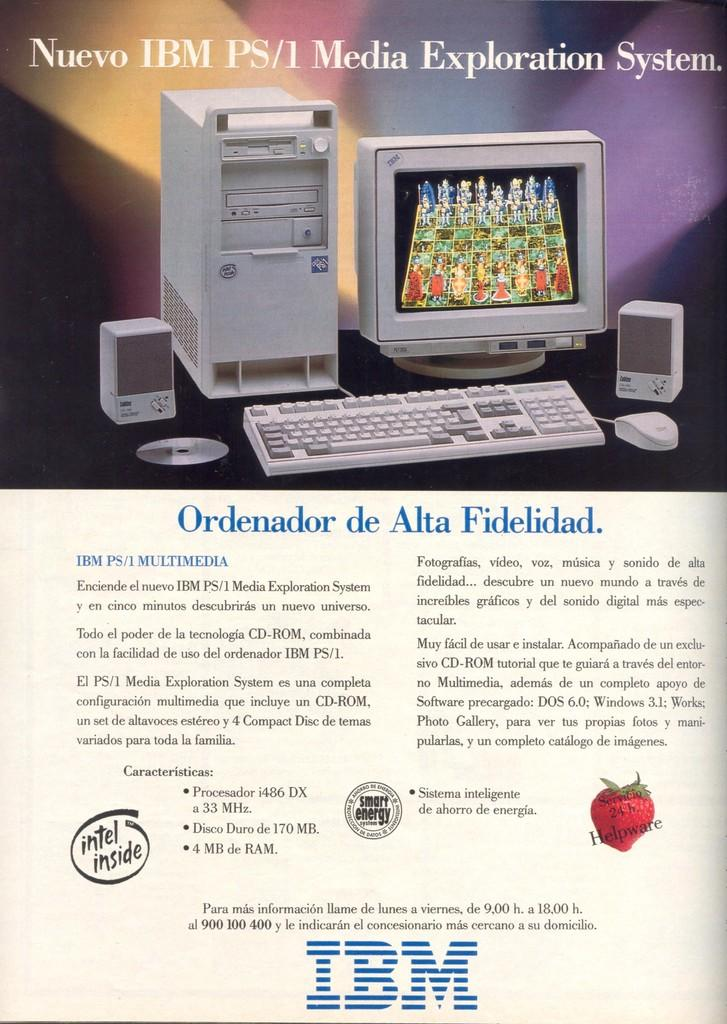<image>
Summarize the visual content of the image. An IBM advertisement shows IBM PS/1 and claims to have Intel inside. 